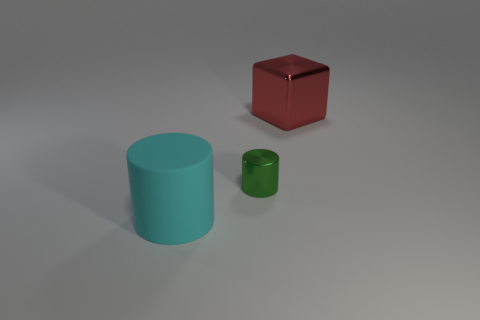Add 3 big gray shiny spheres. How many objects exist? 6 Subtract all cylinders. How many objects are left? 1 Subtract 1 cylinders. How many cylinders are left? 1 Subtract all green cylinders. Subtract all gray cubes. How many cylinders are left? 1 Subtract all red cubes. How many cyan cylinders are left? 1 Subtract all small brown cubes. Subtract all green objects. How many objects are left? 2 Add 2 cyan rubber cylinders. How many cyan rubber cylinders are left? 3 Add 1 big blue cylinders. How many big blue cylinders exist? 1 Subtract all green cylinders. How many cylinders are left? 1 Subtract 0 brown balls. How many objects are left? 3 